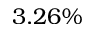Convert formula to latex. <formula><loc_0><loc_0><loc_500><loc_500>3 . 2 6 \%</formula> 